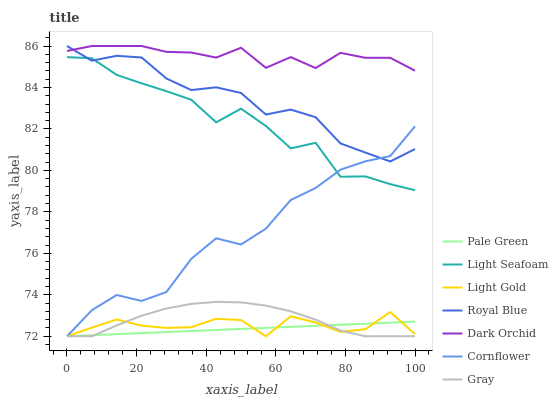Does Pale Green have the minimum area under the curve?
Answer yes or no. Yes. Does Dark Orchid have the maximum area under the curve?
Answer yes or no. Yes. Does Gray have the minimum area under the curve?
Answer yes or no. No. Does Gray have the maximum area under the curve?
Answer yes or no. No. Is Pale Green the smoothest?
Answer yes or no. Yes. Is Light Seafoam the roughest?
Answer yes or no. Yes. Is Gray the smoothest?
Answer yes or no. No. Is Gray the roughest?
Answer yes or no. No. Does Cornflower have the lowest value?
Answer yes or no. Yes. Does Dark Orchid have the lowest value?
Answer yes or no. No. Does Royal Blue have the highest value?
Answer yes or no. Yes. Does Gray have the highest value?
Answer yes or no. No. Is Light Gold less than Light Seafoam?
Answer yes or no. Yes. Is Light Seafoam greater than Pale Green?
Answer yes or no. Yes. Does Cornflower intersect Light Seafoam?
Answer yes or no. Yes. Is Cornflower less than Light Seafoam?
Answer yes or no. No. Is Cornflower greater than Light Seafoam?
Answer yes or no. No. Does Light Gold intersect Light Seafoam?
Answer yes or no. No. 